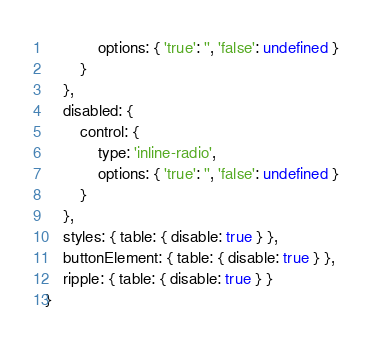Convert code to text. <code><loc_0><loc_0><loc_500><loc_500><_JavaScript_>			options: { 'true': '', 'false': undefined }
		}
	},
	disabled: {
		control: {
			type: 'inline-radio',
			options: { 'true': '', 'false': undefined }
		}
	},
	styles: { table: { disable: true } },
	buttonElement: { table: { disable: true } },
	ripple: { table: { disable: true } }
}
</code> 